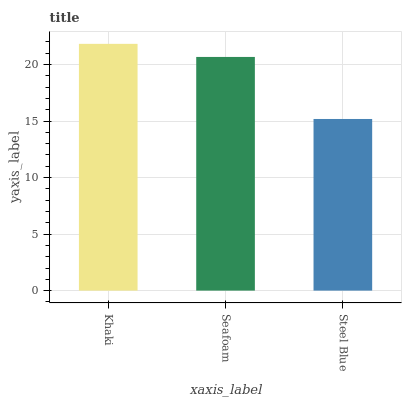Is Steel Blue the minimum?
Answer yes or no. Yes. Is Khaki the maximum?
Answer yes or no. Yes. Is Seafoam the minimum?
Answer yes or no. No. Is Seafoam the maximum?
Answer yes or no. No. Is Khaki greater than Seafoam?
Answer yes or no. Yes. Is Seafoam less than Khaki?
Answer yes or no. Yes. Is Seafoam greater than Khaki?
Answer yes or no. No. Is Khaki less than Seafoam?
Answer yes or no. No. Is Seafoam the high median?
Answer yes or no. Yes. Is Seafoam the low median?
Answer yes or no. Yes. Is Khaki the high median?
Answer yes or no. No. Is Khaki the low median?
Answer yes or no. No. 